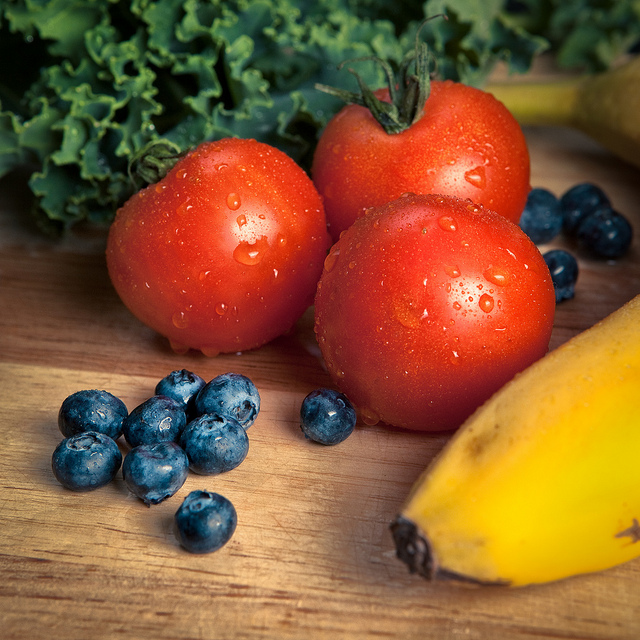<image>What fruit is black in color? It's ambiguous what black fruit is shown as it can be either blueberries, blackberry or grapes. What fruit is black in color? I am not sure what fruit is black in color. It can be either blueberries, blackberry or grapes. 